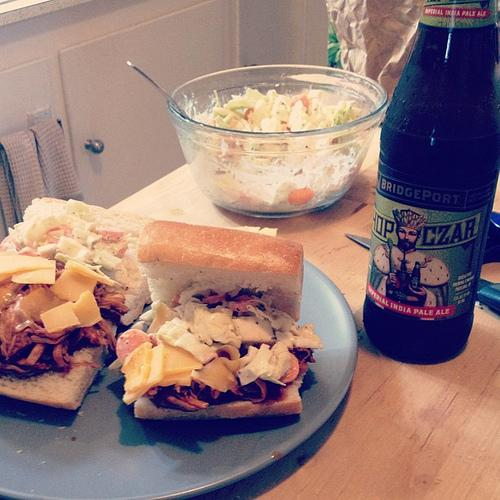Describe any accessory or decoration hanging from the cabinet. There are plaid dish towels hanging from the cabinet. What type of salad is present in the image, and in what type of container is it served? There is potato salad in a clear glass bowl. Identify the primary focus of the image and provide a brief description. The image mainly features a homemade pulled pork and cheese sandwich cut in half, laid on a blue plate, accompanied by a glass bowl of salad and a bottle of pale ale beer. What is the color and shape of the plate holding the sandwiches? The plate is pale blue in color and round in shape. What is the counter made of, and what is its color? The counter is made of wood and has a light brown color. What type of beer can be seen in the image, and is it in a can or a bottle? An imperial india pale ale is in a dark bottle. How many types of sandwiches can be seen in the image, and are they open or closed? There are two open faced sandwiches cut in half, making a total of four sandwich pieces. Describe the position and color of the utensil found in the image. A large silver spoon is sticking out from the salad bowl. Mention three key ingredients seen in the sandwich from the image. Sliced orange cheddar cheese, white cheese slices, and pulled meat are the key ingredients in the sandwich. Provide a concise summary of the key elements found in the image. The image displays a blue plate with a homemade pulled pork sandwich, a clear glass bowl of potato salad, and a dark bottle of pale ale beer on a wooden table. What is the color of the sauce on the plate? The sauce is light pink in color. What kind of beer is in the image? A dark bottle of pale ale, called Imperial India Pale Ale, is in the image. Is the bottle of ale green in color? The instruction is misleading because the bottle of ale is described as "dark", not green. What objects are hanging from the cabinet? Plaid dish towels are hanging from the cabinet. What is the color of the bowl containing the salad? The bowl is clear with no color. Is the cabinet color yellow? The instruction is misleading because the cabinet is described as white, not yellow. Analyze the interaction between the sandwich and the plate. The sandwich is placed on the plate and they are in direct contact with each other. The plate supports the sandwich. Is the counter made of marble? The instruction is misleading because the counter is made of wood, not marble. Can you see a fork in the potato salad? The instruction is misleading because there is a spoon in the potato salad, not a fork. Identify the type of cheese used in the sandwich. Both sliced cheddar and white cheese slices are used in the sandwich. Read any visible text on the beer bottle. Imperial India Pale Ale, Hop Czar Beer Label, Beer manufactured in Bridgeport. Is the sandwich placed on a green plate? The instruction is misleading because the plate is actually blue, not green. What type of counter is the salad bowl placed on? The salad bowl is placed on a wooden counter. Does the image have a pale blue dinner plate or blue round plate? The image has a blue round plate. Describe the appearance of the cabinet in the image. The cabinet is white with a small silver knob and has plaid dish towels hanging from it. Where is the sandwich placed in the image? The sandwich is on a blue round plate. Find any unusual aspects in the image. There is a tiny brown spot on the blue plate, which might be an anomaly. Which bread is used in the sandwich? White sandwich bread is used in the sandwich. How does this kitchen scene make you feel? It feels inviting and cozy, as it seems homemade and well-prepared. Identify the referent for "pulled meat in a sandwich." Pulled meat refers to the brown pieces of meat in the open-faced sandwiches on the blue plate. Describe the appearance of the table and counter in the image. Both the table and counter are made of wood, with the counter having a lighter brown color while the table is darker brown. Describe the salad in the image. The salad is in a clear glass bowl on the wooden counter, and there is a large spoon inside the bowl. Describe the segmentation of the sandwich ingredients. The sandwich has sliced cheddar cheese, white cheese slices, and pieces of brown pulled meat on white bread. Can you find a pasta salad in the bowl? The instruction is misleading because the bowl contains cole slaw, not pasta salad. Provide an assessment of the image quality. The image has clear and well-defined objects with multiple fine details visible. Is the blue plate on the table or counter? The blue plate is on the wooden counter. 